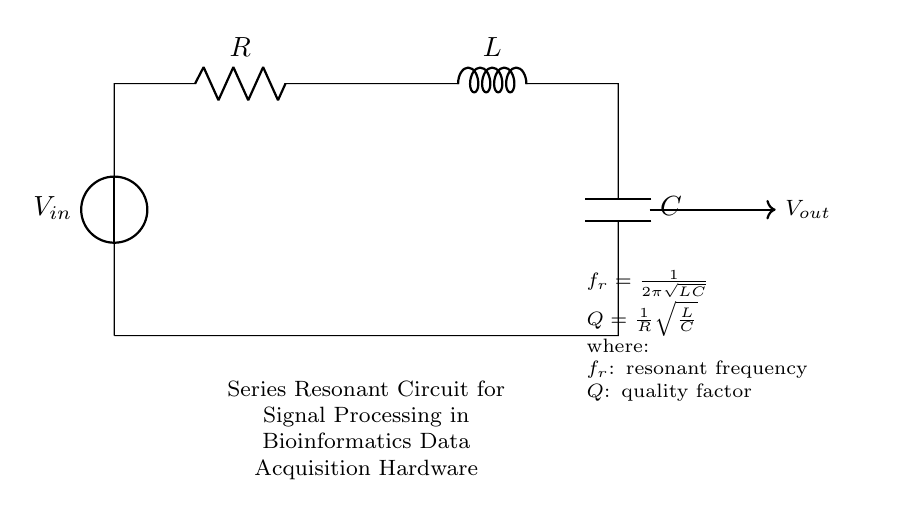What is the resonant frequency formula for the circuit? The resonant frequency formula, as indicated in the circuit diagram, is given as \( f_r = \frac{1}{2\pi\sqrt{LC}} \). This is derived from the nature of a resonant circuit where the inductance (L) and capacitance (C) determine the frequency at which the circuit naturally oscillates.
Answer: frequency equals one over two pi square root LC What does the quality factor represent in this circuit? The quality factor (Q) in the circuit, presented as \( Q = \frac{1}{R}\sqrt{\frac{L}{C}} \), represents the ratio of the inductive reactance to the resistive component, highlighting the efficiency of the circuit at resonance. A higher Q indicates a lower energy loss and sharper resonance peak.
Answer: efficiency What component is placed in parallel with the output? The output in this series resonant circuit does not connect to any component in parallel but directly measures the voltage across the series components. Thus, there are no parallel components shown in the diagram.
Answer: none What is the function of the resistor in this circuit? The resistor (R) in the series resonant circuit serves to dampen the oscillations and limit the current, affecting the overall quality factor and the bandwidth of the resonance. Its value determines how quickly energy is lost in the circuit.
Answer: dampening What is the role of the inductor in the resonant circuit? The inductor (L) in the circuit stores energy in the form of a magnetic field when current passes through it. Together with the capacitor, it determines the resonant frequency by influencing how energy oscillates back and forth between the inductor and capacitor.
Answer: energy storage 